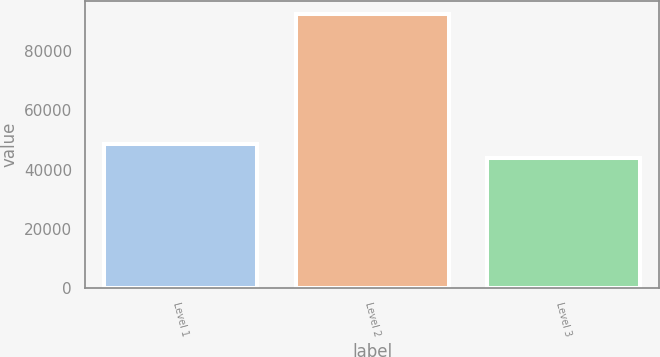Convert chart to OTSL. <chart><loc_0><loc_0><loc_500><loc_500><bar_chart><fcel>Level 1<fcel>Level 2<fcel>Level 3<nl><fcel>48647.6<fcel>92330<fcel>43794<nl></chart> 